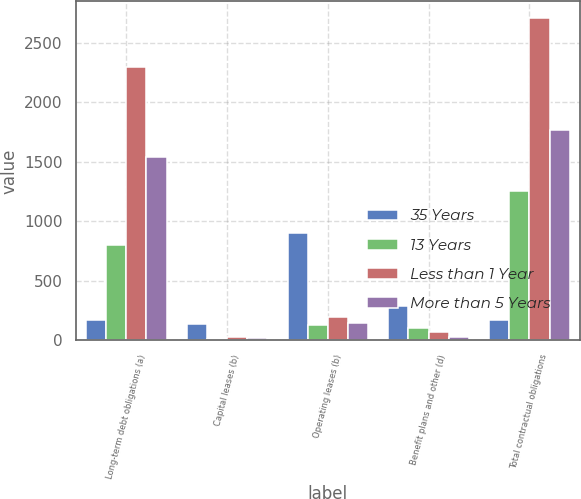Convert chart to OTSL. <chart><loc_0><loc_0><loc_500><loc_500><stacked_bar_chart><ecel><fcel>Long-term debt obligations (a)<fcel>Capital leases (b)<fcel>Operating leases (b)<fcel>Benefit plans and other (d)<fcel>Total contractual obligations<nl><fcel>35 Years<fcel>170<fcel>136<fcel>899<fcel>284<fcel>170<nl><fcel>13 Years<fcel>801<fcel>13<fcel>124<fcel>100<fcel>1254<nl><fcel>Less than 1 Year<fcel>2301<fcel>25<fcel>198<fcel>66<fcel>2713<nl><fcel>More than 5 Years<fcel>1538<fcel>22<fcel>142<fcel>26<fcel>1766<nl></chart> 